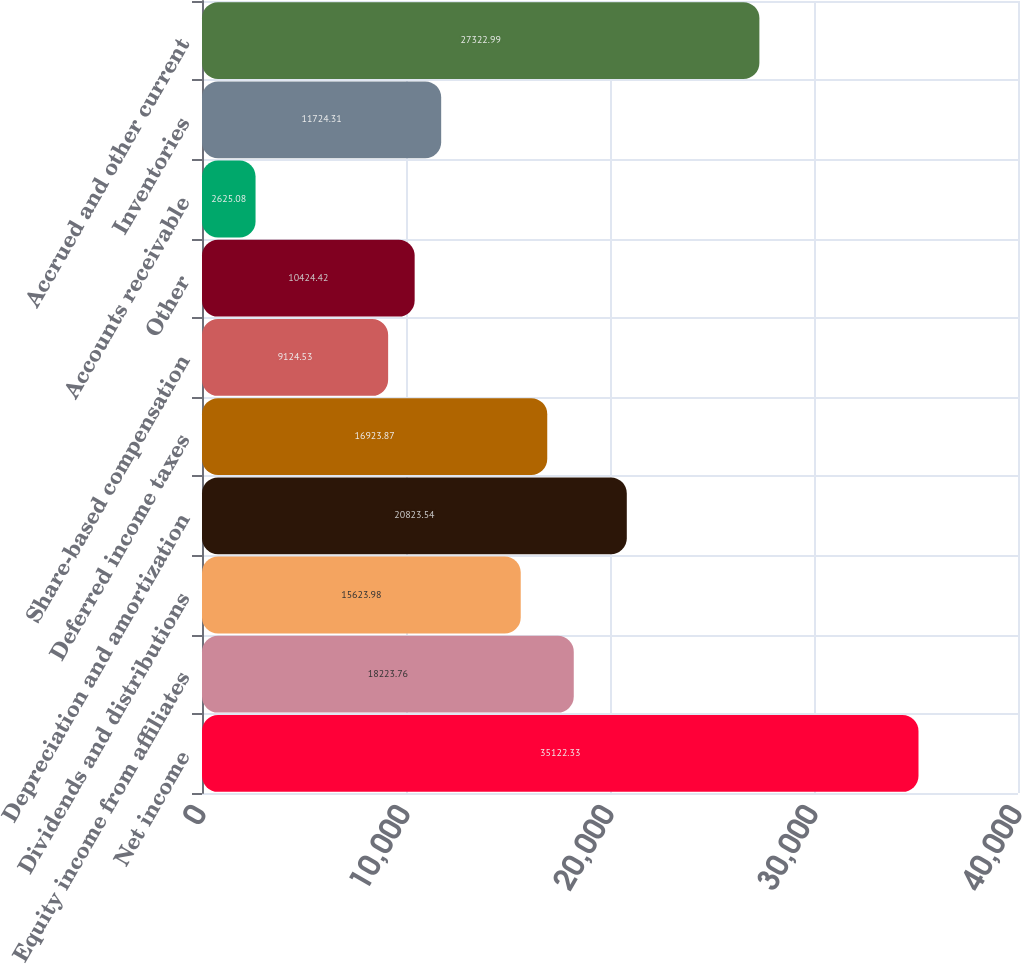Convert chart. <chart><loc_0><loc_0><loc_500><loc_500><bar_chart><fcel>Net income<fcel>Equity income from affiliates<fcel>Dividends and distributions<fcel>Depreciation and amortization<fcel>Deferred income taxes<fcel>Share-based compensation<fcel>Other<fcel>Accounts receivable<fcel>Inventories<fcel>Accrued and other current<nl><fcel>35122.3<fcel>18223.8<fcel>15624<fcel>20823.5<fcel>16923.9<fcel>9124.53<fcel>10424.4<fcel>2625.08<fcel>11724.3<fcel>27323<nl></chart> 